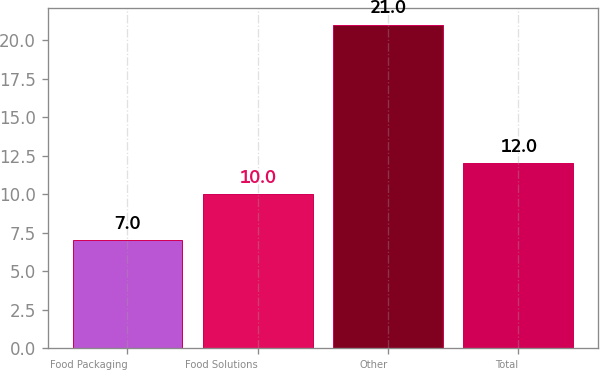<chart> <loc_0><loc_0><loc_500><loc_500><bar_chart><fcel>Food Packaging<fcel>Food Solutions<fcel>Other<fcel>Total<nl><fcel>7<fcel>10<fcel>21<fcel>12<nl></chart> 